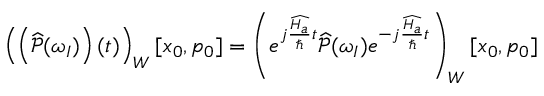<formula> <loc_0><loc_0><loc_500><loc_500>\left ( \left ( \widehat { \mathcal { P } } ( \omega _ { I } ) \right ) ( t ) \right ) _ { W } [ x _ { 0 } , p _ { 0 } ] = \left ( e ^ { j \frac { \widehat { H _ { a } } } { } t } \widehat { \mathcal { P } } ( \omega _ { I } ) e ^ { - j \frac { \widehat { H _ { a } } } { } t } \right ) _ { W } [ x _ { 0 } , p _ { 0 } ]</formula> 